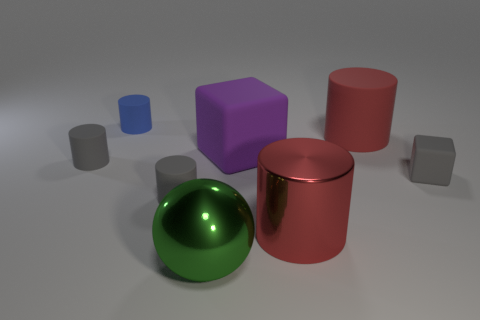There is a metallic thing to the right of the large thing that is left of the big purple rubber thing; how many large red metallic objects are to the right of it?
Give a very brief answer. 0. There is a large thing that is behind the tiny gray block and on the left side of the red shiny thing; what is its material?
Your answer should be compact. Rubber. Do the large green thing and the red cylinder in front of the big purple object have the same material?
Your answer should be compact. Yes. Are there more blue cylinders in front of the purple rubber cube than large green metal balls behind the green metal sphere?
Give a very brief answer. No. What is the shape of the purple rubber thing?
Ensure brevity in your answer.  Cube. Does the block on the right side of the big matte cylinder have the same material as the large cylinder behind the large red metal cylinder?
Ensure brevity in your answer.  Yes. There is a gray object that is to the right of the large green ball; what shape is it?
Your answer should be compact. Cube. There is a metal thing that is the same shape as the small blue matte object; what size is it?
Provide a succinct answer. Large. Does the big sphere have the same color as the tiny block?
Make the answer very short. No. Is there anything else that is the same shape as the blue object?
Ensure brevity in your answer.  Yes. 